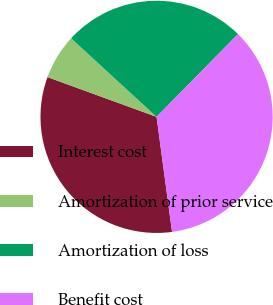<chart> <loc_0><loc_0><loc_500><loc_500><pie_chart><fcel>Interest cost<fcel>Amortization of prior service<fcel>Amortization of loss<fcel>Benefit cost<nl><fcel>32.69%<fcel>6.27%<fcel>25.54%<fcel>35.5%<nl></chart> 